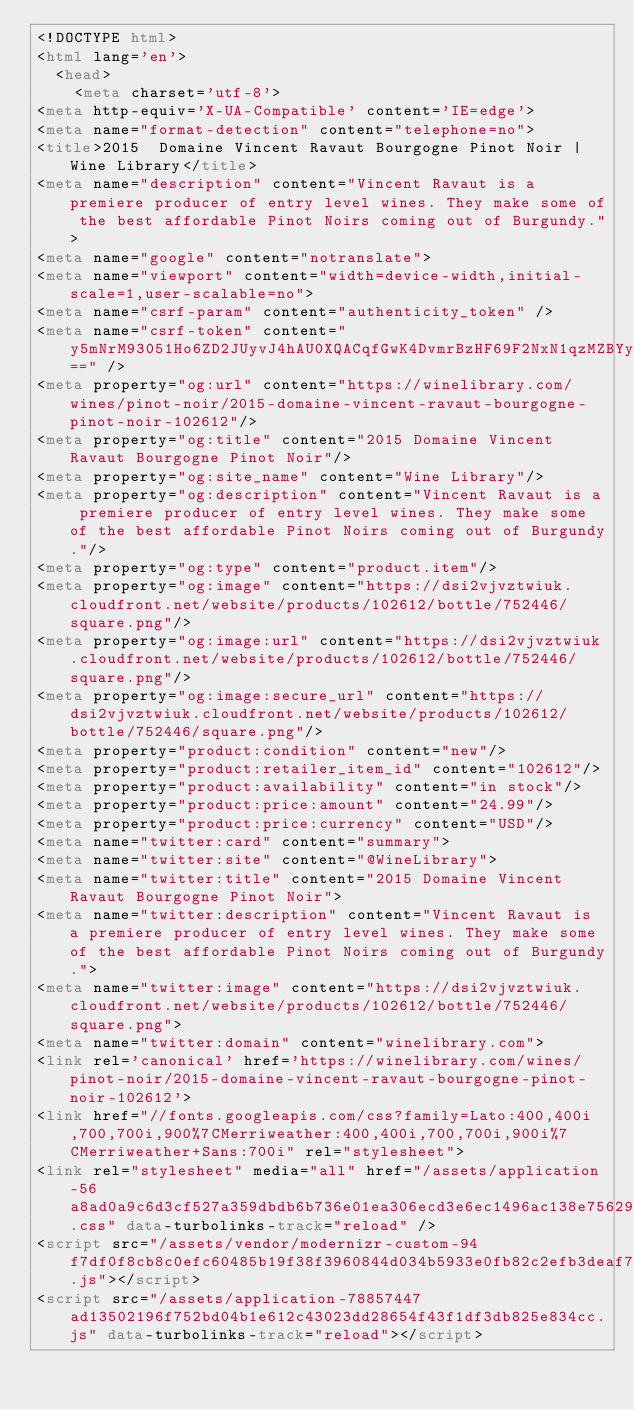Convert code to text. <code><loc_0><loc_0><loc_500><loc_500><_HTML_><!DOCTYPE html>
<html lang='en'>
  <head>
    <meta charset='utf-8'>
<meta http-equiv='X-UA-Compatible' content='IE=edge'>
<meta name="format-detection" content="telephone=no">
<title>2015  Domaine Vincent Ravaut Bourgogne Pinot Noir | Wine Library</title>
<meta name="description" content="Vincent Ravaut is a premiere producer of entry level wines. They make some of the best affordable Pinot Noirs coming out of Burgundy.">
<meta name="google" content="notranslate">
<meta name="viewport" content="width=device-width,initial-scale=1,user-scalable=no">
<meta name="csrf-param" content="authenticity_token" />
<meta name="csrf-token" content="y5mNrM93051Ho6ZD2JUyvJ4hAU0XQACqfGwK4DvmrBzHF69F2NxN1qzMZBYyeDiRJOOKrYHaVtaSynjgwRzDsQ==" />
<meta property="og:url" content="https://winelibrary.com/wines/pinot-noir/2015-domaine-vincent-ravaut-bourgogne-pinot-noir-102612"/>
<meta property="og:title" content="2015 Domaine Vincent Ravaut Bourgogne Pinot Noir"/>
<meta property="og:site_name" content="Wine Library"/>
<meta property="og:description" content="Vincent Ravaut is a premiere producer of entry level wines. They make some of the best affordable Pinot Noirs coming out of Burgundy."/>
<meta property="og:type" content="product.item"/>
<meta property="og:image" content="https://dsi2vjvztwiuk.cloudfront.net/website/products/102612/bottle/752446/square.png"/>
<meta property="og:image:url" content="https://dsi2vjvztwiuk.cloudfront.net/website/products/102612/bottle/752446/square.png"/>
<meta property="og:image:secure_url" content="https://dsi2vjvztwiuk.cloudfront.net/website/products/102612/bottle/752446/square.png"/>
<meta property="product:condition" content="new"/>
<meta property="product:retailer_item_id" content="102612"/>
<meta property="product:availability" content="in stock"/>
<meta property="product:price:amount" content="24.99"/>
<meta property="product:price:currency" content="USD"/>
<meta name="twitter:card" content="summary">
<meta name="twitter:site" content="@WineLibrary">
<meta name="twitter:title" content="2015 Domaine Vincent Ravaut Bourgogne Pinot Noir">
<meta name="twitter:description" content="Vincent Ravaut is a premiere producer of entry level wines. They make some of the best affordable Pinot Noirs coming out of Burgundy.">
<meta name="twitter:image" content="https://dsi2vjvztwiuk.cloudfront.net/website/products/102612/bottle/752446/square.png">
<meta name="twitter:domain" content="winelibrary.com">
<link rel='canonical' href='https://winelibrary.com/wines/pinot-noir/2015-domaine-vincent-ravaut-bourgogne-pinot-noir-102612'>
<link href="//fonts.googleapis.com/css?family=Lato:400,400i,700,700i,900%7CMerriweather:400,400i,700,700i,900i%7CMerriweather+Sans:700i" rel="stylesheet">
<link rel="stylesheet" media="all" href="/assets/application-56a8ad0a9c6d3cf527a359dbdb6b736e01ea306ecd3e6ec1496ac138e75629fc.css" data-turbolinks-track="reload" />
<script src="/assets/vendor/modernizr-custom-94f7df0f8cb8c0efc60485b19f38f3960844d034b5933e0fb82c2efb3deaf7cc.js"></script>
<script src="/assets/application-78857447ad13502196f752bd04b1e612c43023dd28654f43f1df3db825e834cc.js" data-turbolinks-track="reload"></script></code> 